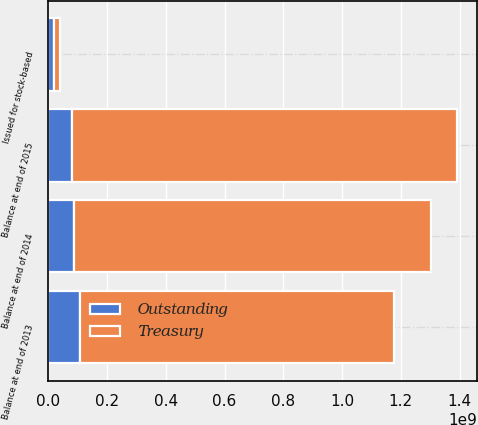<chart> <loc_0><loc_0><loc_500><loc_500><stacked_bar_chart><ecel><fcel>Balance at end of 2013<fcel>Issued for stock-based<fcel>Balance at end of 2014<fcel>Balance at end of 2015<nl><fcel>Outstanding<fcel>1.06896e+08<fcel>1.97455e+07<fcel>8.71502e+07<fcel>8.10511e+07<nl><fcel>Treasury<fcel>1.07101e+09<fcel>1.97455e+07<fcel>1.21666e+09<fcel>1.31016e+09<nl></chart> 